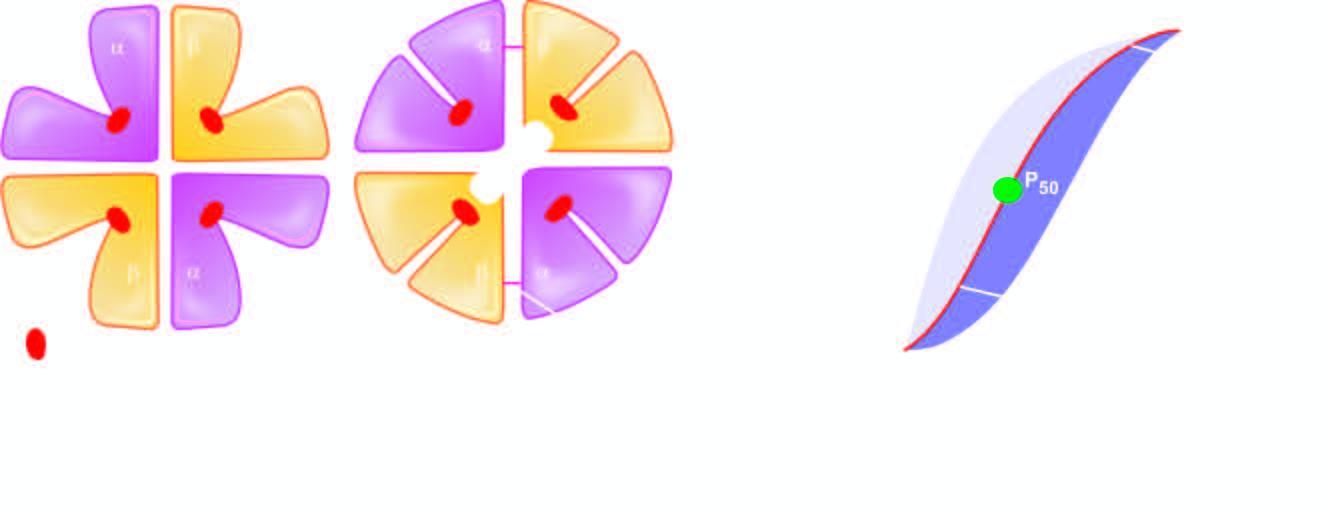re salt bridges formed again?
Answer the question using a single word or phrase. Yes 